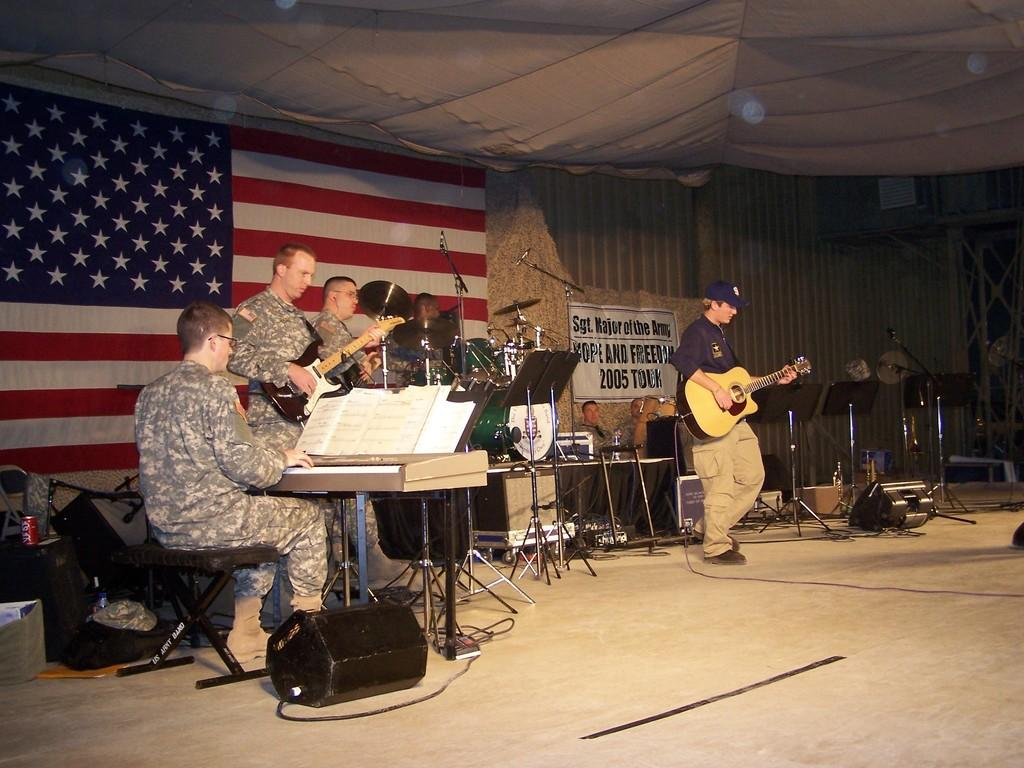What type of people are present in the image? There are military people in the image. What are the military people doing in the image? The military people are using musical instruments. Can you identify any equipment used for amplifying sound in the image? Yes, there is a microphone in the image. What national symbol can be seen in the background of the image? There is an American flag in the background of the image. Who is the owner of the rice in the image? There is no rice present in the image, so it is not possible to determine an owner. 